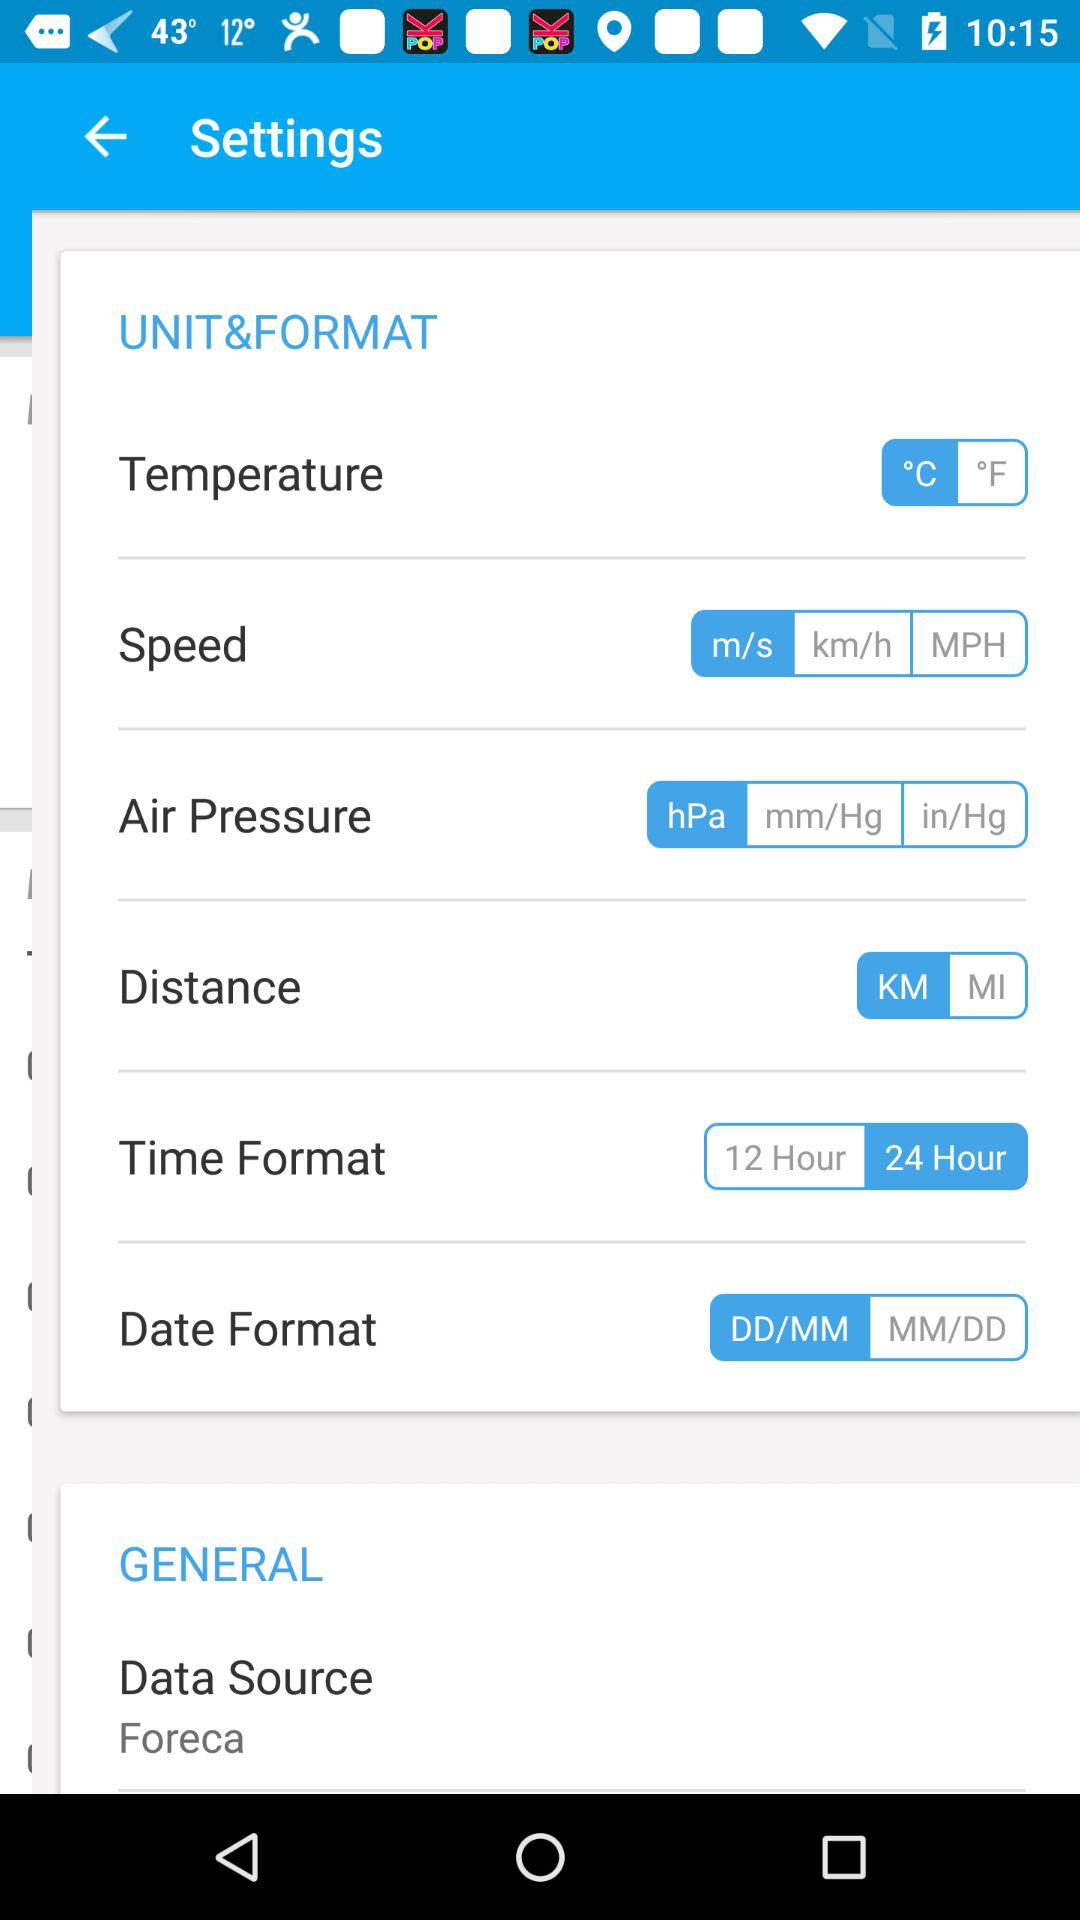Which date format is selected? The selected date format is DD/MM. 